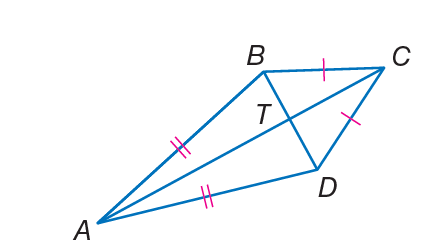Is it possible to determine the type of triangle ACD from the image and given angle measures? Based on the image and the given angle measures, triangle ACD can be partially characterized. We know that angle BCD is 50 degrees, and if we know the measure of angle CAD or angle ADC, we could determine more about the type of triangle ACD. For example, if any of the angles were 90 degrees, it would be a right triangle. If all angles were less than 90 degrees, it would be acute, and if one angle were greater than 90 degrees, it would be obtuse. Without additional measures, however, we cannot fully determine the triangle type. As shown in the enhanced answer, if angle ADC is indeed 234 degrees, this would not be possible in a real triangle, indicating an inconsistency in the information provided. 